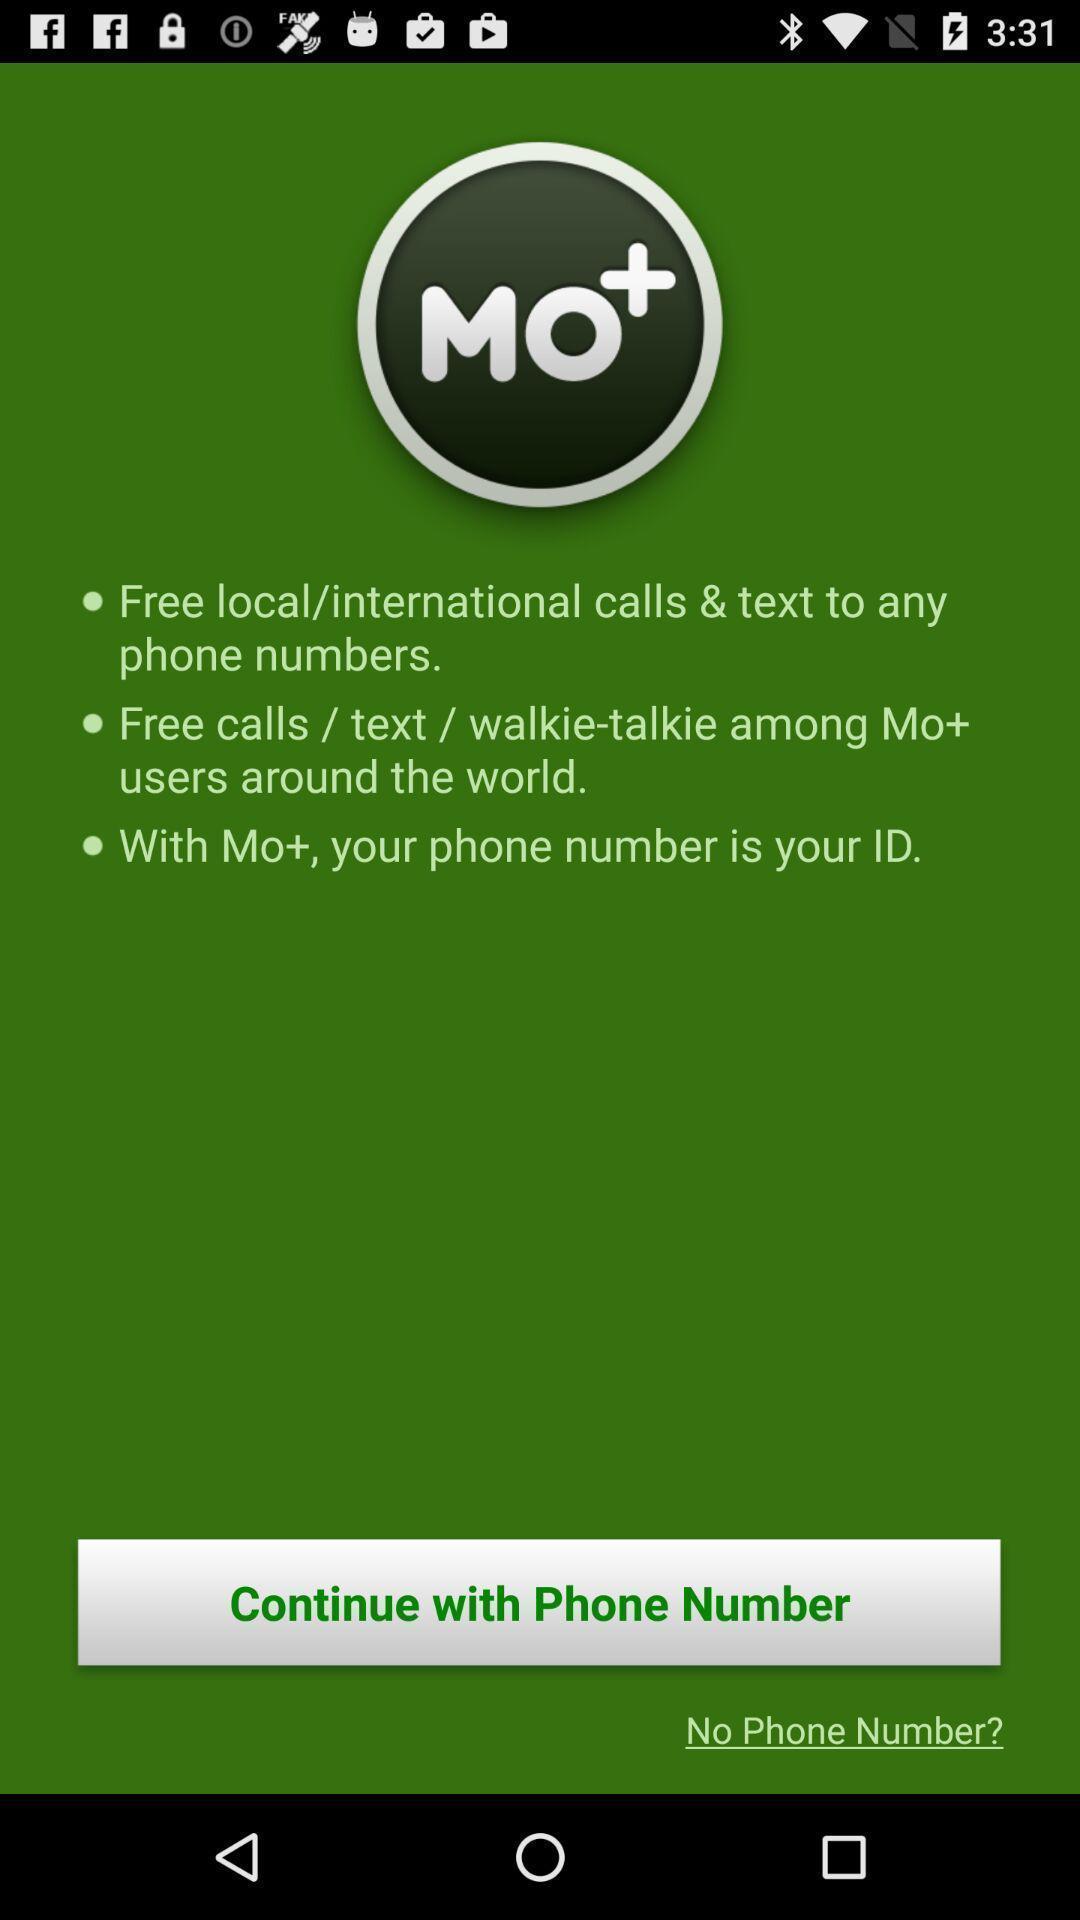Describe this image in words. Screen shows continue option in a call app. 